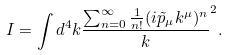Convert formula to latex. <formula><loc_0><loc_0><loc_500><loc_500>I = \int d ^ { 4 } k \frac { \sum _ { n = 0 } ^ { \infty } \frac { 1 } { n ! } ( i \tilde { p } _ { \mu } k ^ { \mu } ) ^ { n } } k ^ { 2 } .</formula> 